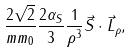<formula> <loc_0><loc_0><loc_500><loc_500>\frac { 2 \sqrt { 2 } } { m m _ { 0 } } \frac { 2 \alpha _ { S } } { 3 } \frac { 1 } { \rho ^ { 3 } } \vec { S } \cdot \vec { L } _ { \rho } ,</formula> 